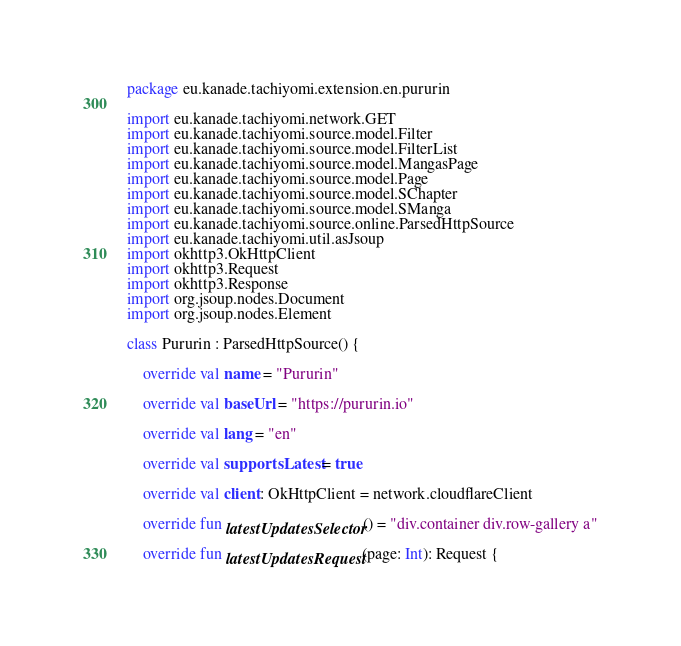<code> <loc_0><loc_0><loc_500><loc_500><_Kotlin_>package eu.kanade.tachiyomi.extension.en.pururin

import eu.kanade.tachiyomi.network.GET
import eu.kanade.tachiyomi.source.model.Filter
import eu.kanade.tachiyomi.source.model.FilterList
import eu.kanade.tachiyomi.source.model.MangasPage
import eu.kanade.tachiyomi.source.model.Page
import eu.kanade.tachiyomi.source.model.SChapter
import eu.kanade.tachiyomi.source.model.SManga
import eu.kanade.tachiyomi.source.online.ParsedHttpSource
import eu.kanade.tachiyomi.util.asJsoup
import okhttp3.OkHttpClient
import okhttp3.Request
import okhttp3.Response
import org.jsoup.nodes.Document
import org.jsoup.nodes.Element

class Pururin : ParsedHttpSource() {

    override val name = "Pururin"

    override val baseUrl = "https://pururin.io"

    override val lang = "en"

    override val supportsLatest = true

    override val client: OkHttpClient = network.cloudflareClient

    override fun latestUpdatesSelector() = "div.container div.row-gallery a"

    override fun latestUpdatesRequest(page: Int): Request {</code> 